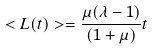<formula> <loc_0><loc_0><loc_500><loc_500>< L ( t ) > = \frac { \mu ( \lambda - 1 ) } { ( 1 + \mu ) } t</formula> 